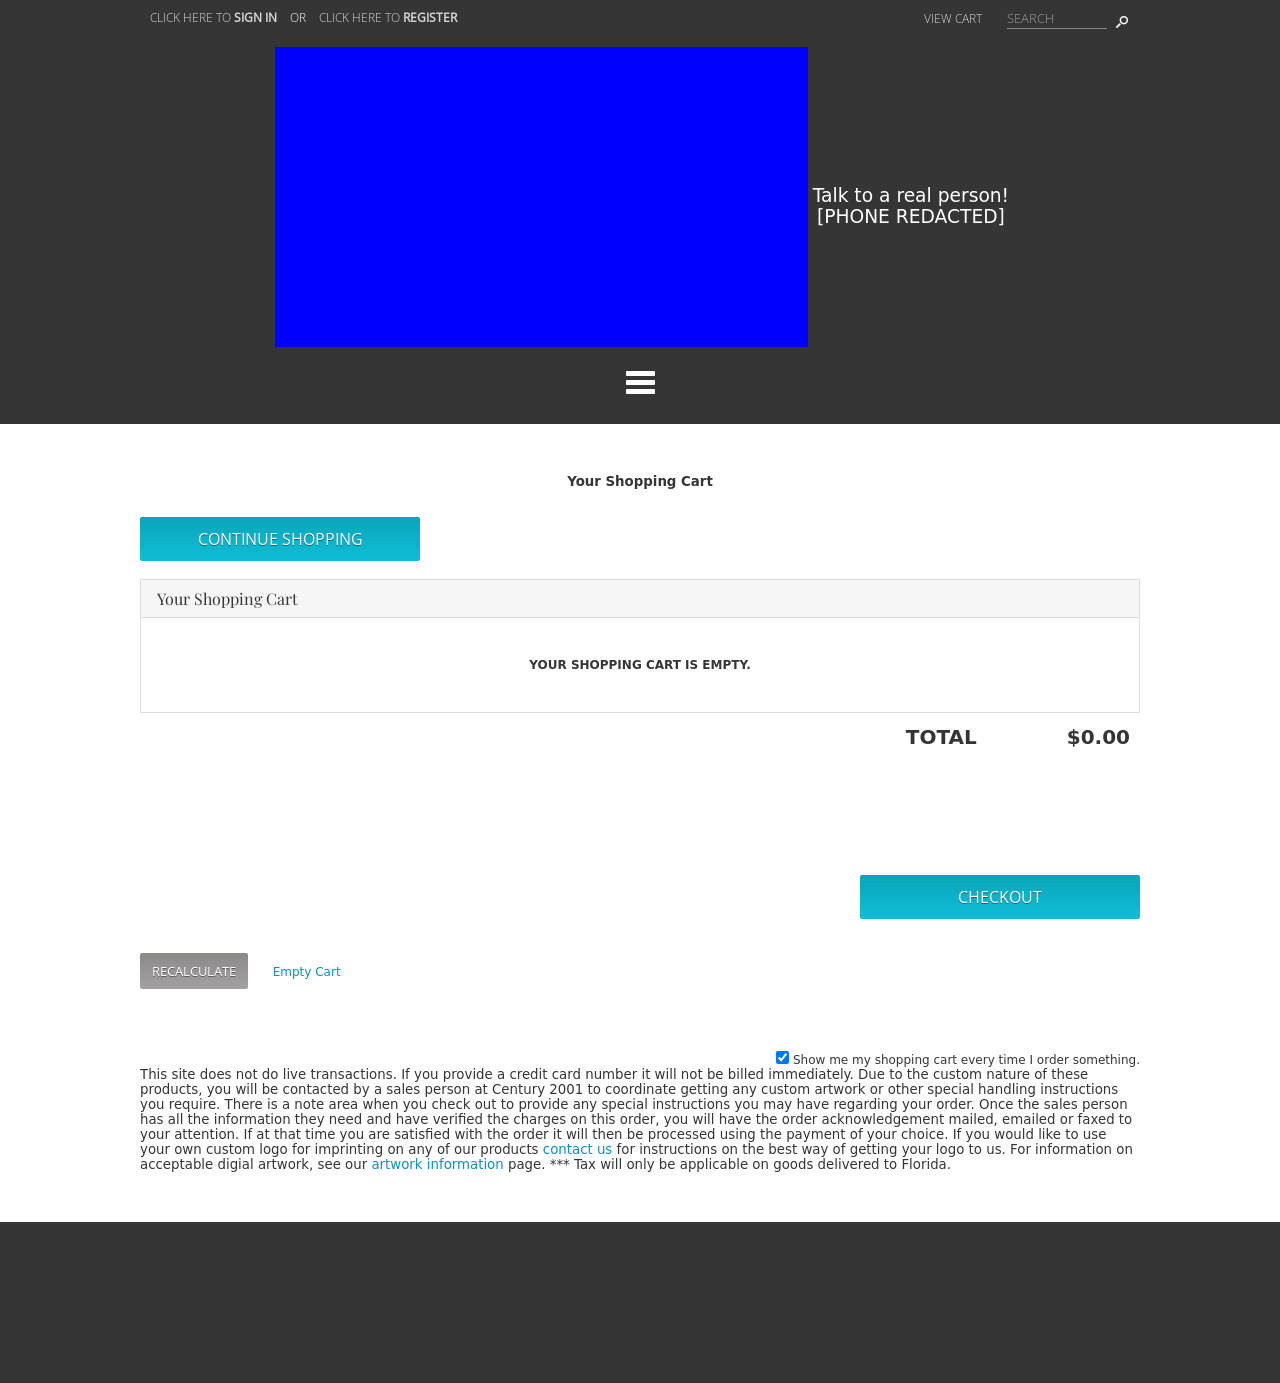What types of images should be used in the shopping cart area to enhance user engagement? Use clear, high-quality images of the products being purchased in the shopping cart area. Consider adding thumbnail previews next to product descriptions to help customers easily visualize what they are buying. Additionally, using icons for actions such as deleting items or adjusting quantities can improve user experience and engagement. 